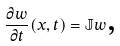Convert formula to latex. <formula><loc_0><loc_0><loc_500><loc_500>\frac { \partial w } { \partial t } ( x , t ) = \mathbb { J } w \text {,}</formula> 